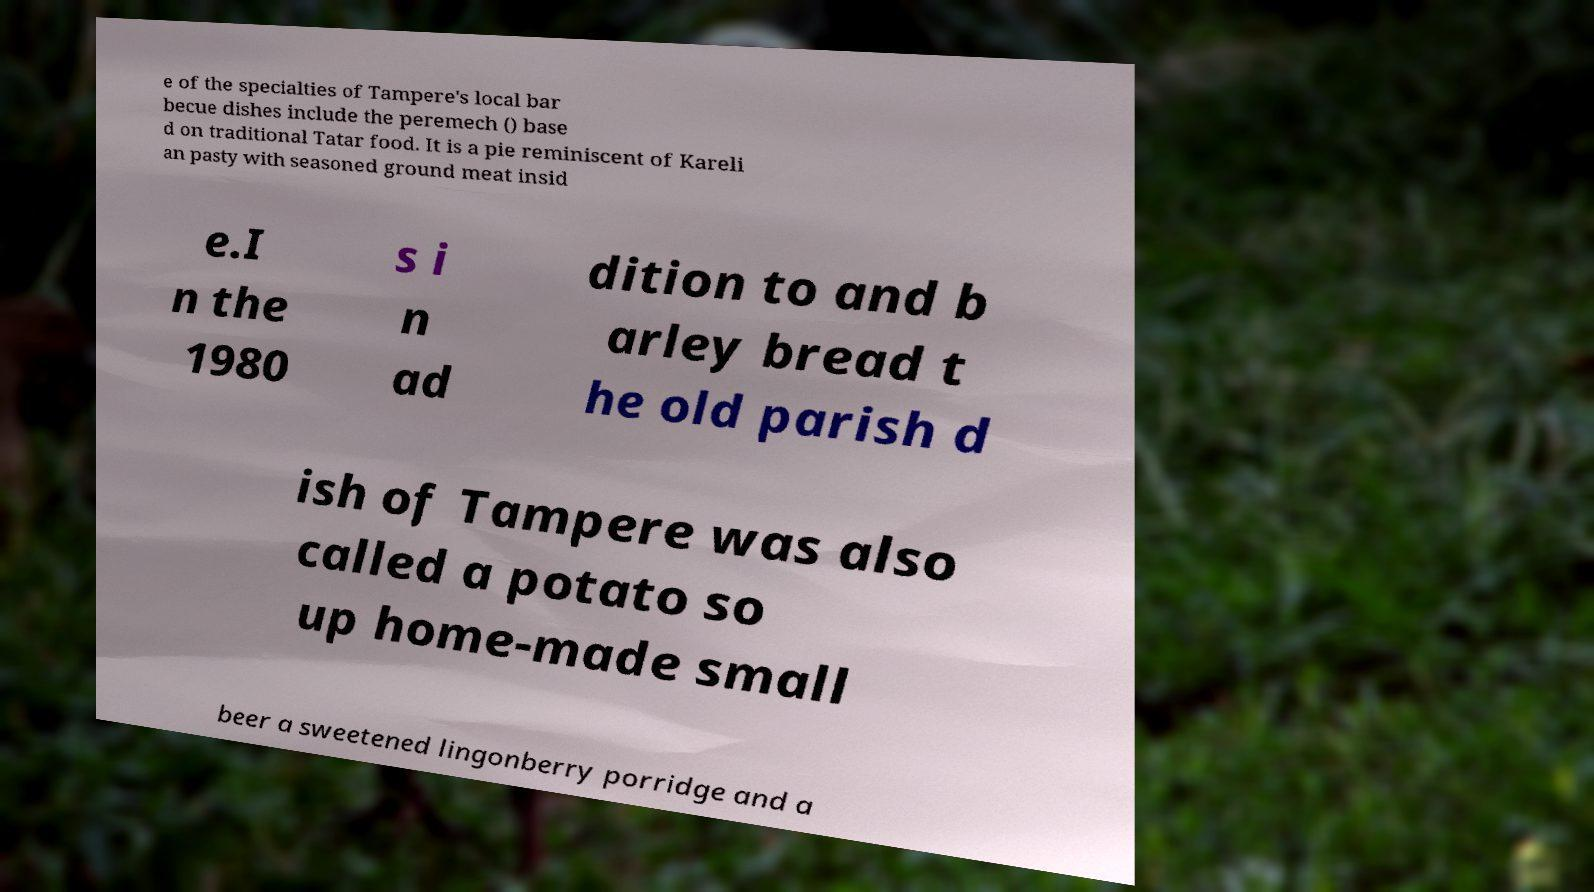There's text embedded in this image that I need extracted. Can you transcribe it verbatim? e of the specialties of Tampere's local bar becue dishes include the peremech () base d on traditional Tatar food. It is a pie reminiscent of Kareli an pasty with seasoned ground meat insid e.I n the 1980 s i n ad dition to and b arley bread t he old parish d ish of Tampere was also called a potato so up home-made small beer a sweetened lingonberry porridge and a 